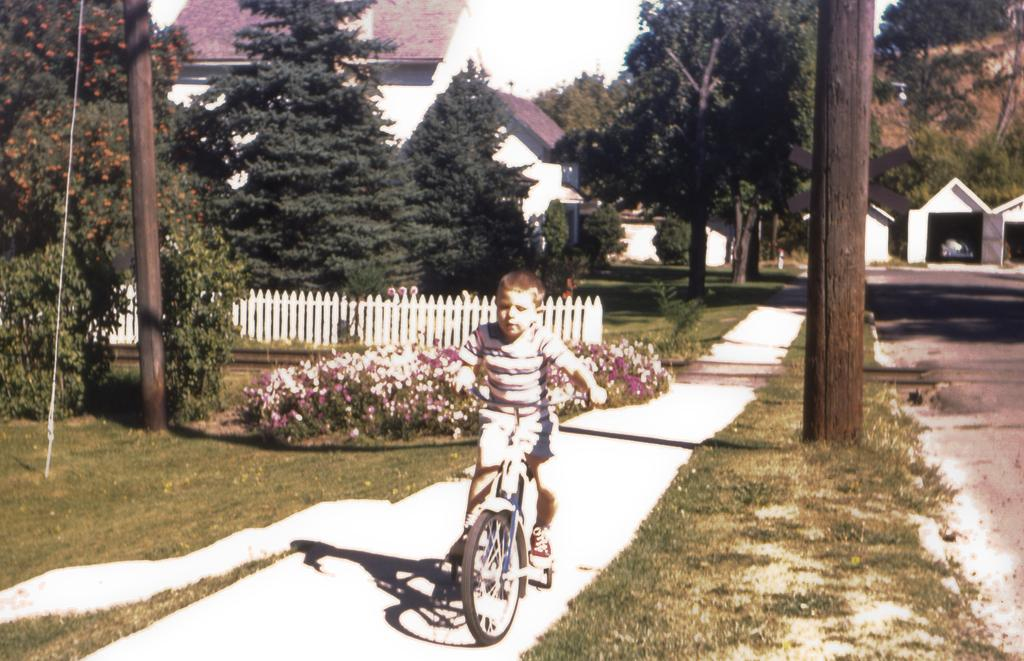What can be seen in the background of the image? There is a house and trees in the background of the image. What is the boy in the image doing? The boy is riding a bicycle in the image. What type of vegetation is present on the ground? The ground is covered with grass, and there are flower plants in the image. What color is the fence in the image? The fence in the image is white. What is the boy's position on the bicycle in the image? The provided facts do not specify the boy's position on the bicycle, so we cannot definitively answer this question. How does the ice affect the bicycle ride in the image? There is no ice present in the image, so it does not affect the bicycle ride. 